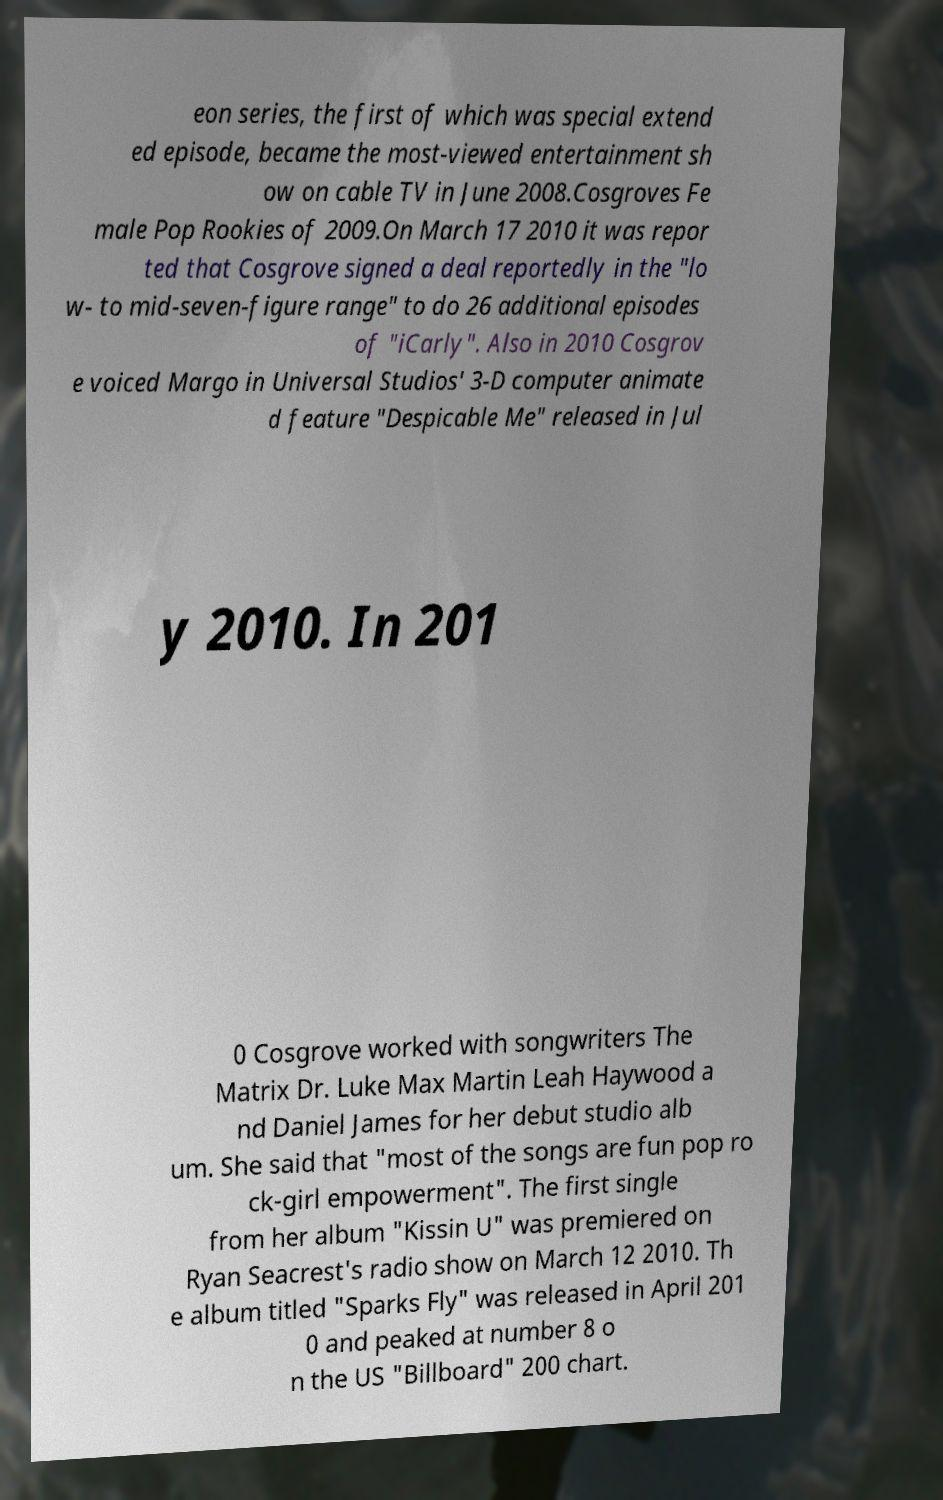Could you extract and type out the text from this image? eon series, the first of which was special extend ed episode, became the most-viewed entertainment sh ow on cable TV in June 2008.Cosgroves Fe male Pop Rookies of 2009.On March 17 2010 it was repor ted that Cosgrove signed a deal reportedly in the "lo w- to mid-seven-figure range" to do 26 additional episodes of "iCarly". Also in 2010 Cosgrov e voiced Margo in Universal Studios' 3-D computer animate d feature "Despicable Me" released in Jul y 2010. In 201 0 Cosgrove worked with songwriters The Matrix Dr. Luke Max Martin Leah Haywood a nd Daniel James for her debut studio alb um. She said that "most of the songs are fun pop ro ck-girl empowerment". The first single from her album "Kissin U" was premiered on Ryan Seacrest's radio show on March 12 2010. Th e album titled "Sparks Fly" was released in April 201 0 and peaked at number 8 o n the US "Billboard" 200 chart. 